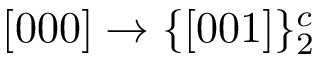Convert formula to latex. <formula><loc_0><loc_0><loc_500><loc_500>[ 0 0 0 ] \rightarrow \{ [ 0 0 1 ] \} _ { 2 } ^ { c }</formula> 